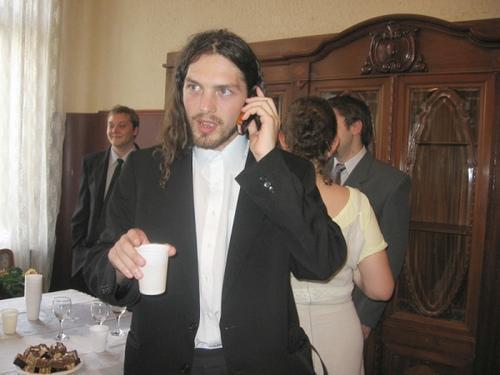What kind of telephone is being used?
From the following set of four choices, select the accurate answer to respond to the question.
Options: Rotary, cellular, pay, landline. Cellular. 